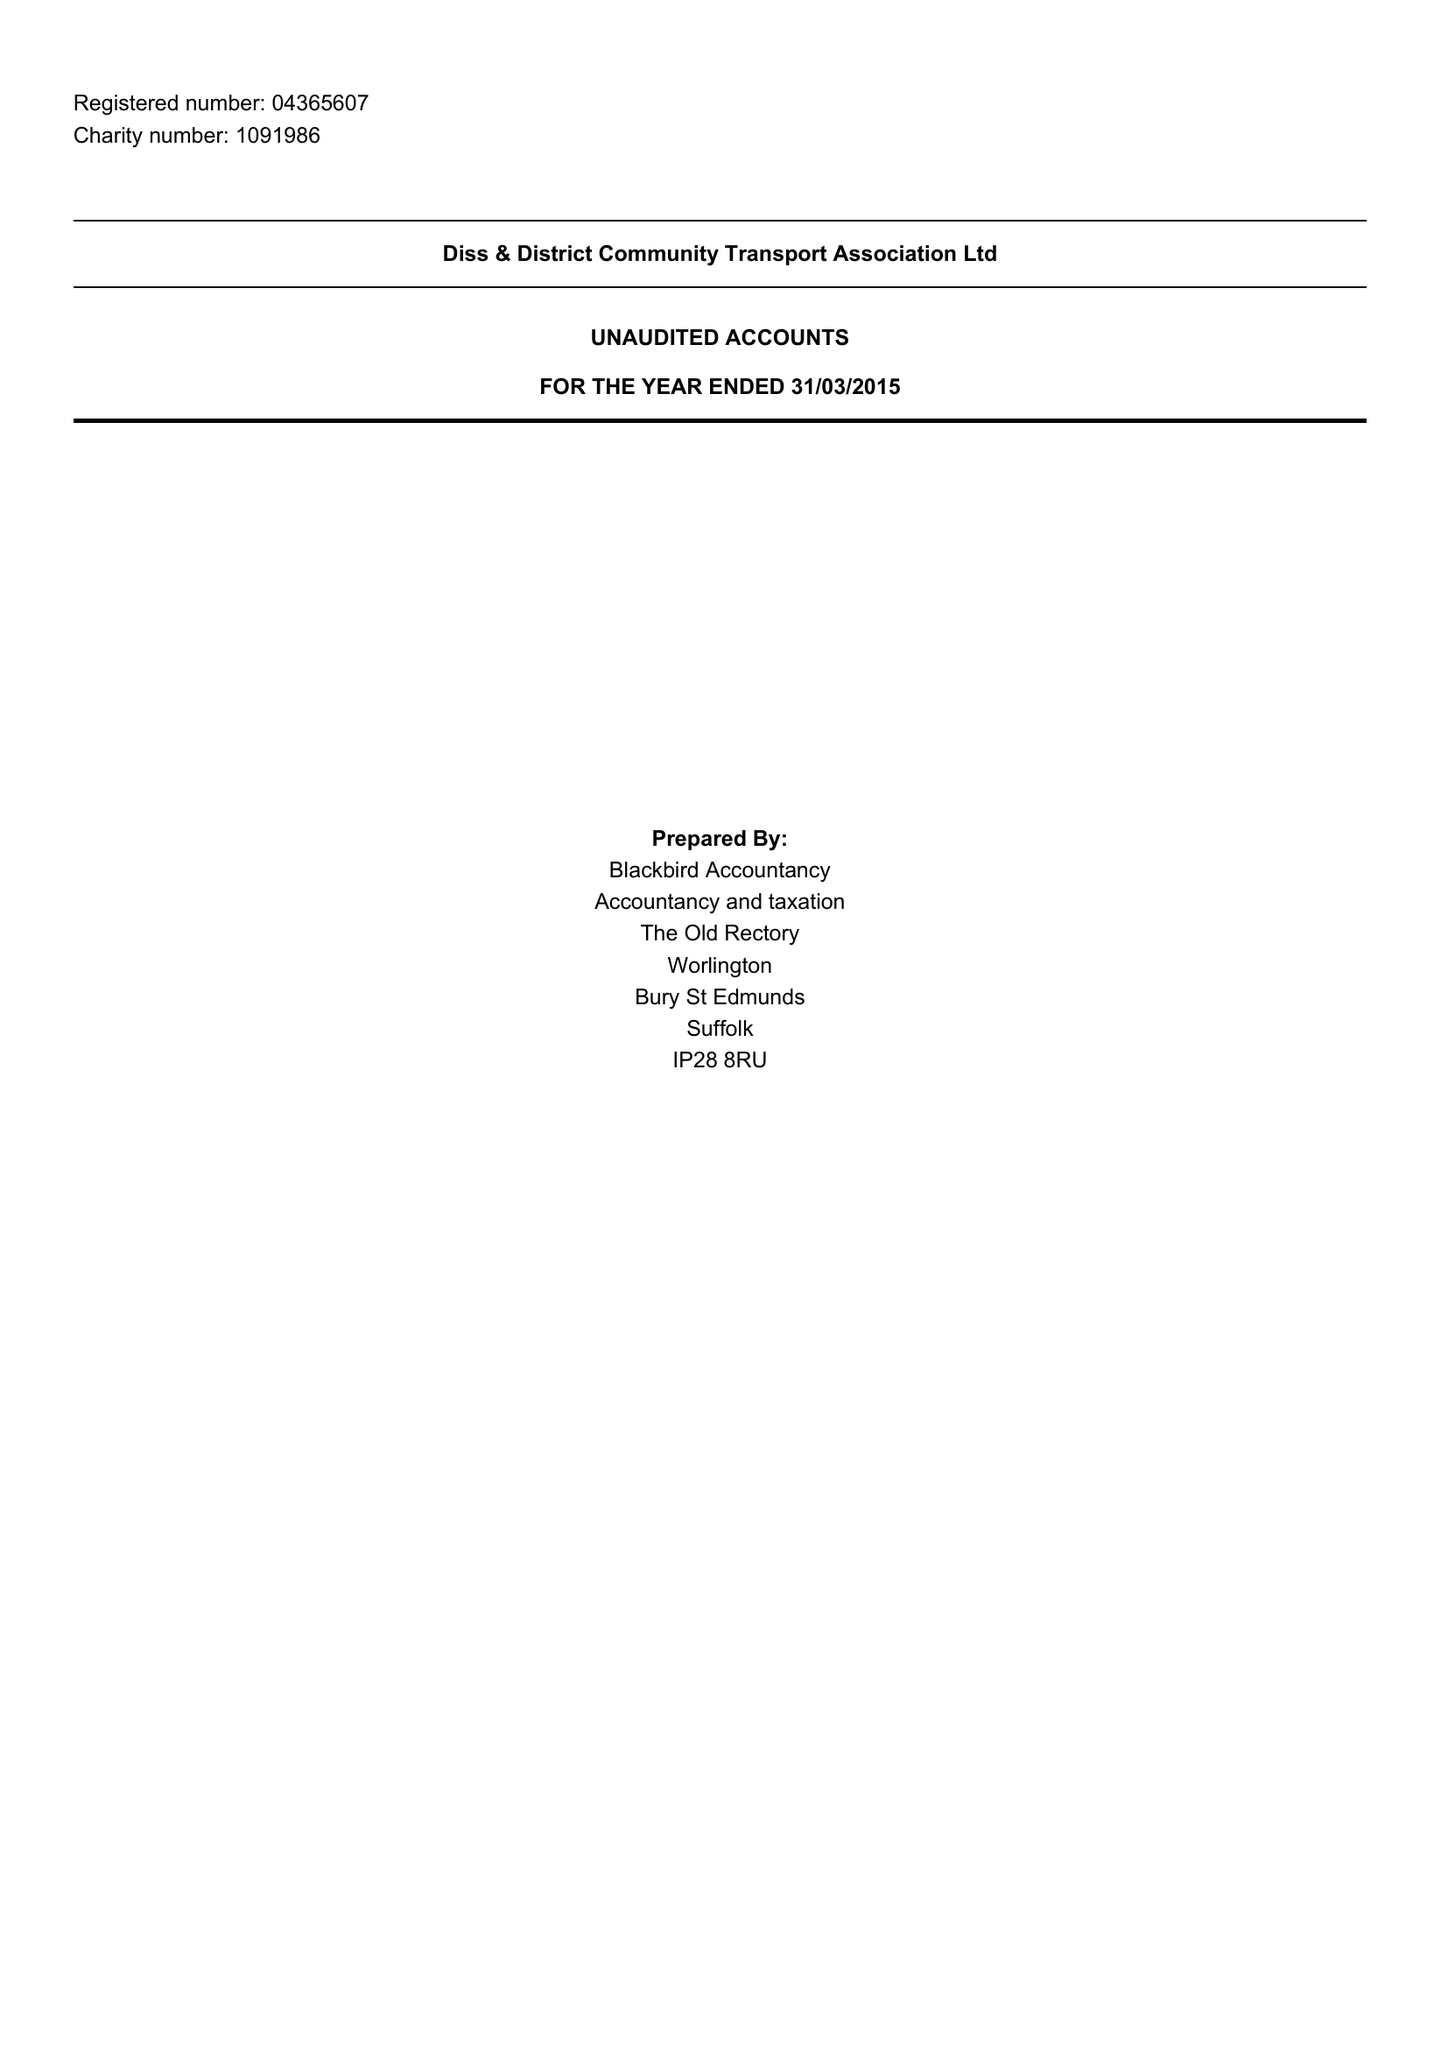What is the value for the spending_annually_in_british_pounds?
Answer the question using a single word or phrase. 252099.00 